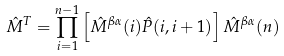Convert formula to latex. <formula><loc_0><loc_0><loc_500><loc_500>\hat { M } ^ { T } = \prod ^ { n - 1 } _ { i = 1 } \left [ \hat { M } ^ { \beta \alpha } ( i ) \hat { P } ( i , i + 1 ) \right ] \hat { M } ^ { \beta \alpha } ( n )</formula> 